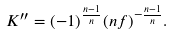<formula> <loc_0><loc_0><loc_500><loc_500>K ^ { \prime \prime } = ( - 1 ) ^ { \frac { n - 1 } { n } } ( n f ) ^ { - \frac { n - 1 } { n } } .</formula> 